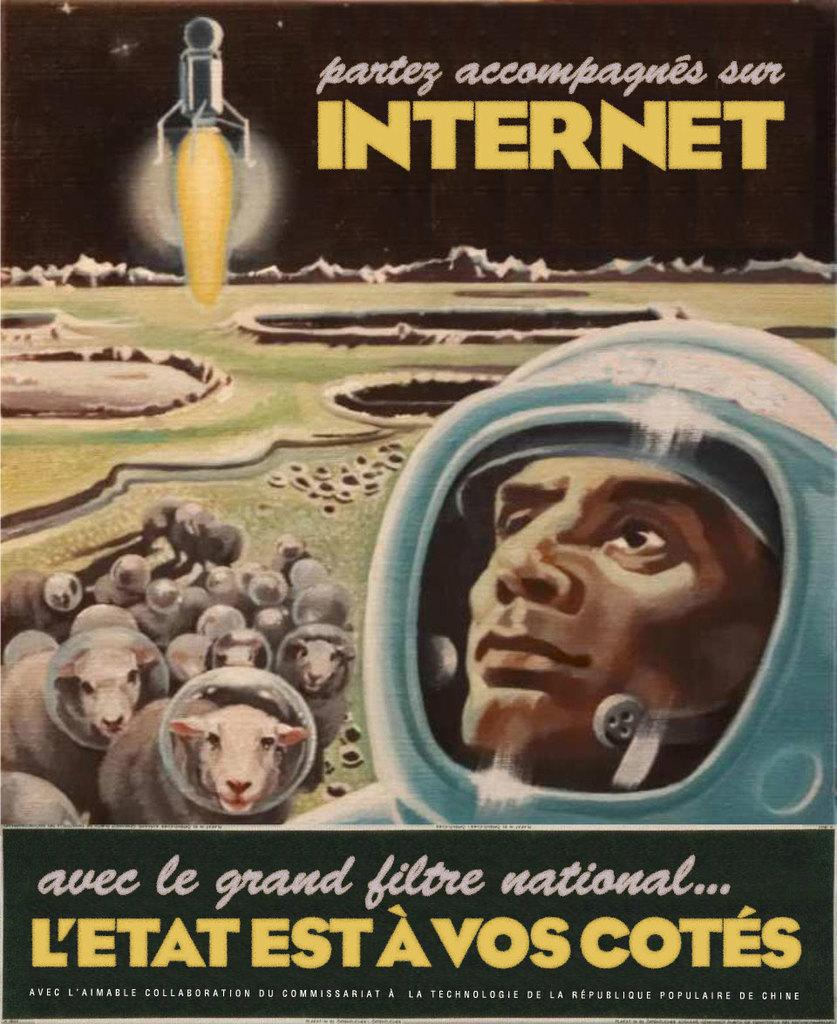<image>
Provide a brief description of the given image. A book with a man and sheep on it called Partez accompagnes sur Internet. 